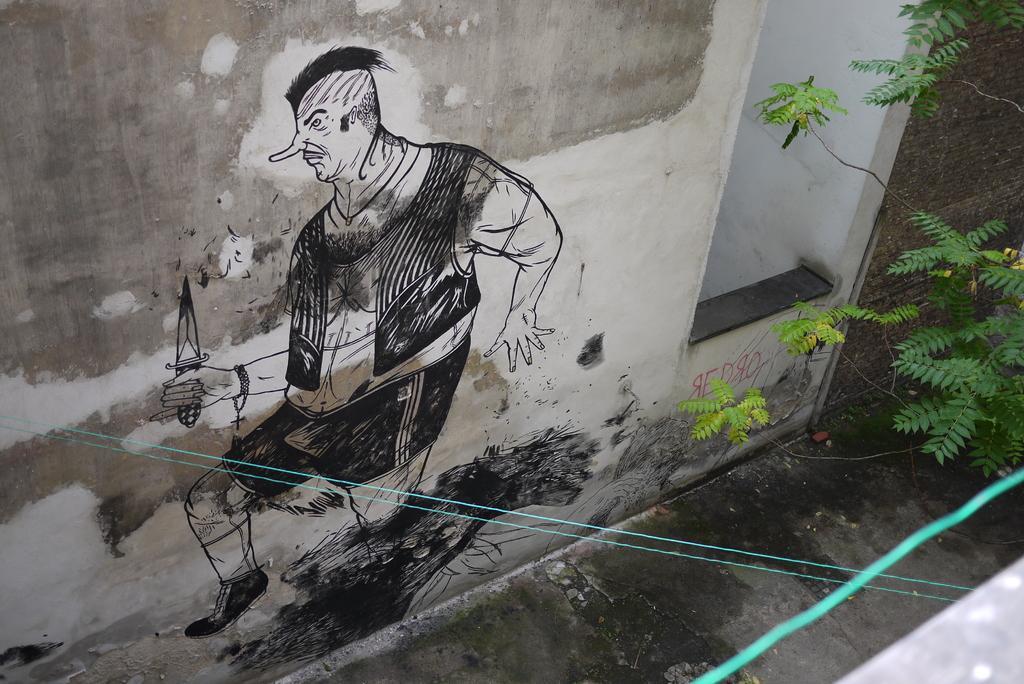Can you describe this image briefly? In this image we can see a wall. On the wall we can see a painting of a person holding a knife. On the right side, we can see the leaves. 